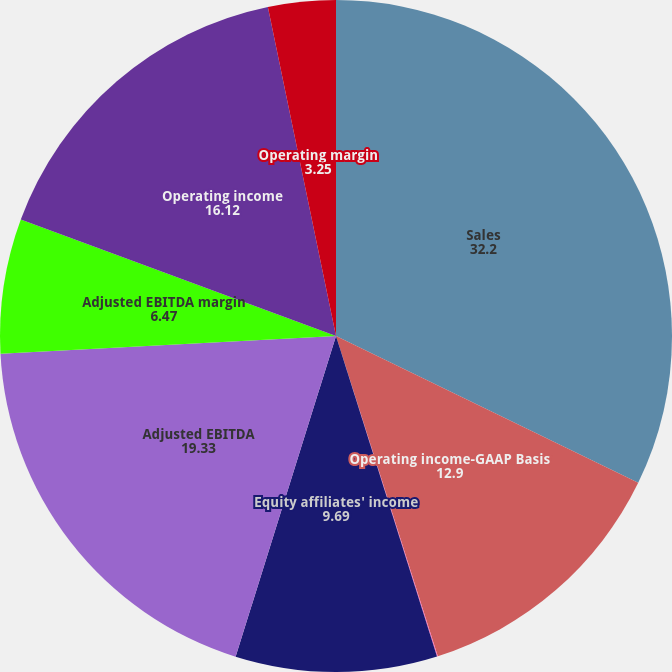Convert chart. <chart><loc_0><loc_0><loc_500><loc_500><pie_chart><fcel>Sales<fcel>Operating income-GAAP Basis<fcel>Operating margin-GAAP Basis<fcel>Equity affiliates' income<fcel>Adjusted EBITDA<fcel>Adjusted EBITDA margin<fcel>Operating income<fcel>Operating margin<nl><fcel>32.2%<fcel>12.9%<fcel>0.04%<fcel>9.69%<fcel>19.33%<fcel>6.47%<fcel>16.12%<fcel>3.25%<nl></chart> 